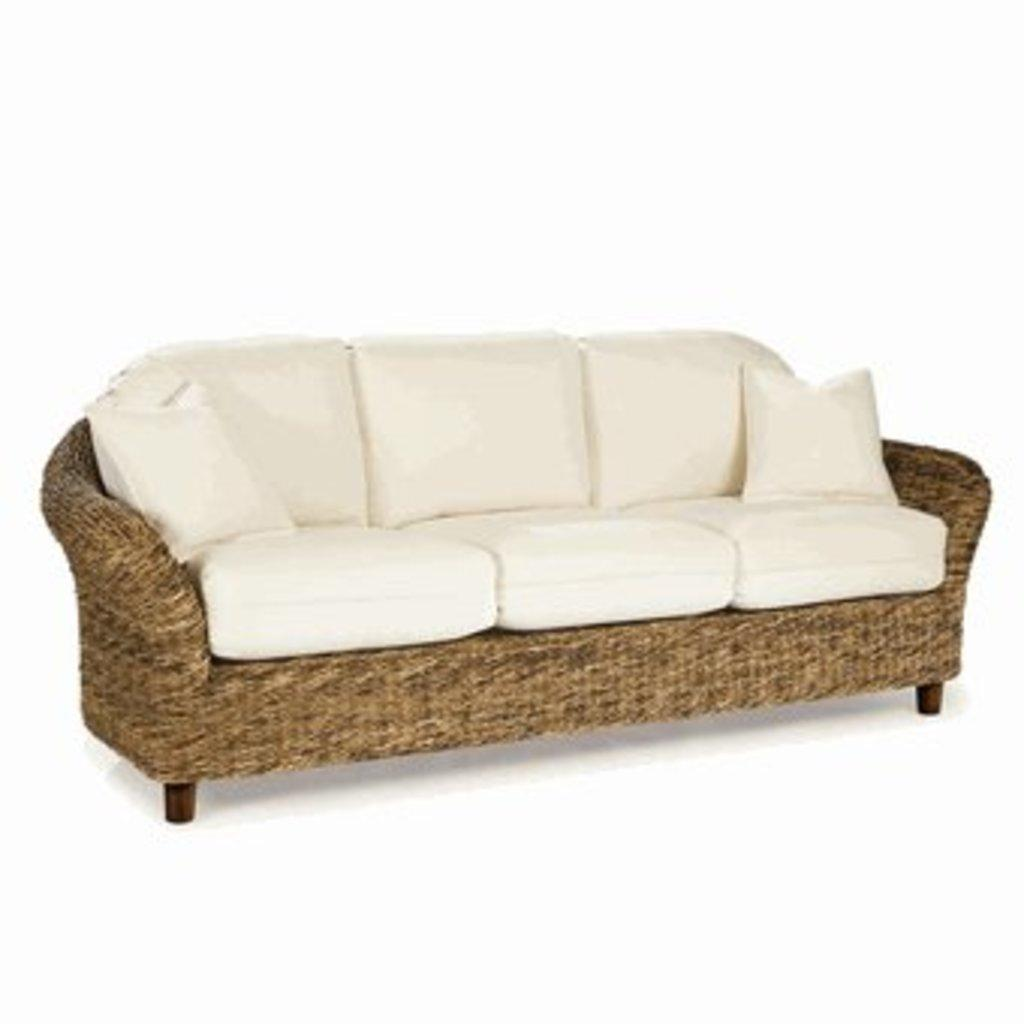What type of sofa is in the image? There is a sea grass sleeper sofa in the image. What can be seen on the sofa? There are two white cushions on the sofa. What color is the background of the image? The background of the image is white in color. How many blades of grass are visible on the sofa? There are no blades of grass visible on the sofa; it is a sea grass sleeper sofa, not a grassy surface. 